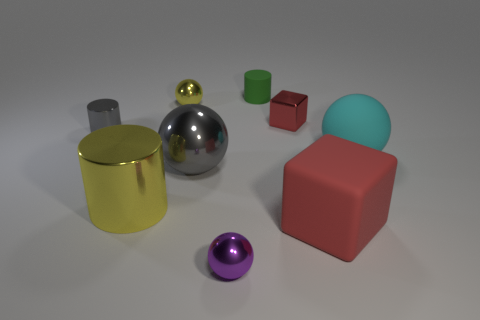The metallic object that is the same color as the small metallic cylinder is what shape?
Your response must be concise. Sphere. What number of big things are shiny spheres or purple things?
Give a very brief answer. 1. Is there a purple shiny object of the same size as the shiny block?
Provide a short and direct response. Yes. What color is the tiny metallic ball behind the tiny object in front of the big ball on the right side of the tiny green rubber object?
Provide a short and direct response. Yellow. Do the large red object and the object that is behind the tiny yellow object have the same material?
Give a very brief answer. Yes. There is another object that is the same shape as the red rubber thing; what size is it?
Keep it short and to the point. Small. Are there an equal number of cyan things in front of the tiny rubber cylinder and matte blocks that are in front of the purple metal sphere?
Your answer should be compact. No. How many other objects are there of the same material as the big cylinder?
Provide a succinct answer. 5. Are there the same number of small red things in front of the small gray thing and purple metal cylinders?
Offer a terse response. Yes. There is a matte cylinder; is its size the same as the sphere right of the big block?
Make the answer very short. No. 